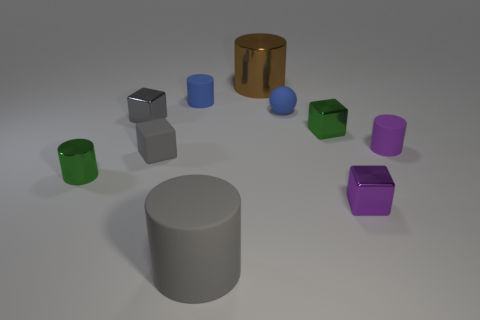What number of rubber objects have the same size as the purple metal thing?
Keep it short and to the point. 4. There is a green thing left of the brown shiny cylinder; is it the same size as the blue sphere?
Ensure brevity in your answer.  Yes. What shape is the thing that is on the right side of the big gray object and behind the small sphere?
Make the answer very short. Cylinder. There is a small gray metal object; are there any tiny gray rubber things to the left of it?
Your response must be concise. No. Is there anything else that is the same shape as the gray shiny thing?
Keep it short and to the point. Yes. Does the big brown thing have the same shape as the purple rubber object?
Give a very brief answer. Yes. Are there the same number of small rubber cylinders that are in front of the small blue ball and green cylinders in front of the tiny purple matte thing?
Your answer should be very brief. Yes. How many tiny things are gray shiny blocks or yellow metal things?
Keep it short and to the point. 1. Is the number of purple cylinders that are behind the small blue rubber sphere the same as the number of gray shiny cubes?
Keep it short and to the point. No. There is a small green metal cube that is on the right side of the small matte ball; is there a tiny purple metallic thing that is behind it?
Ensure brevity in your answer.  No. 